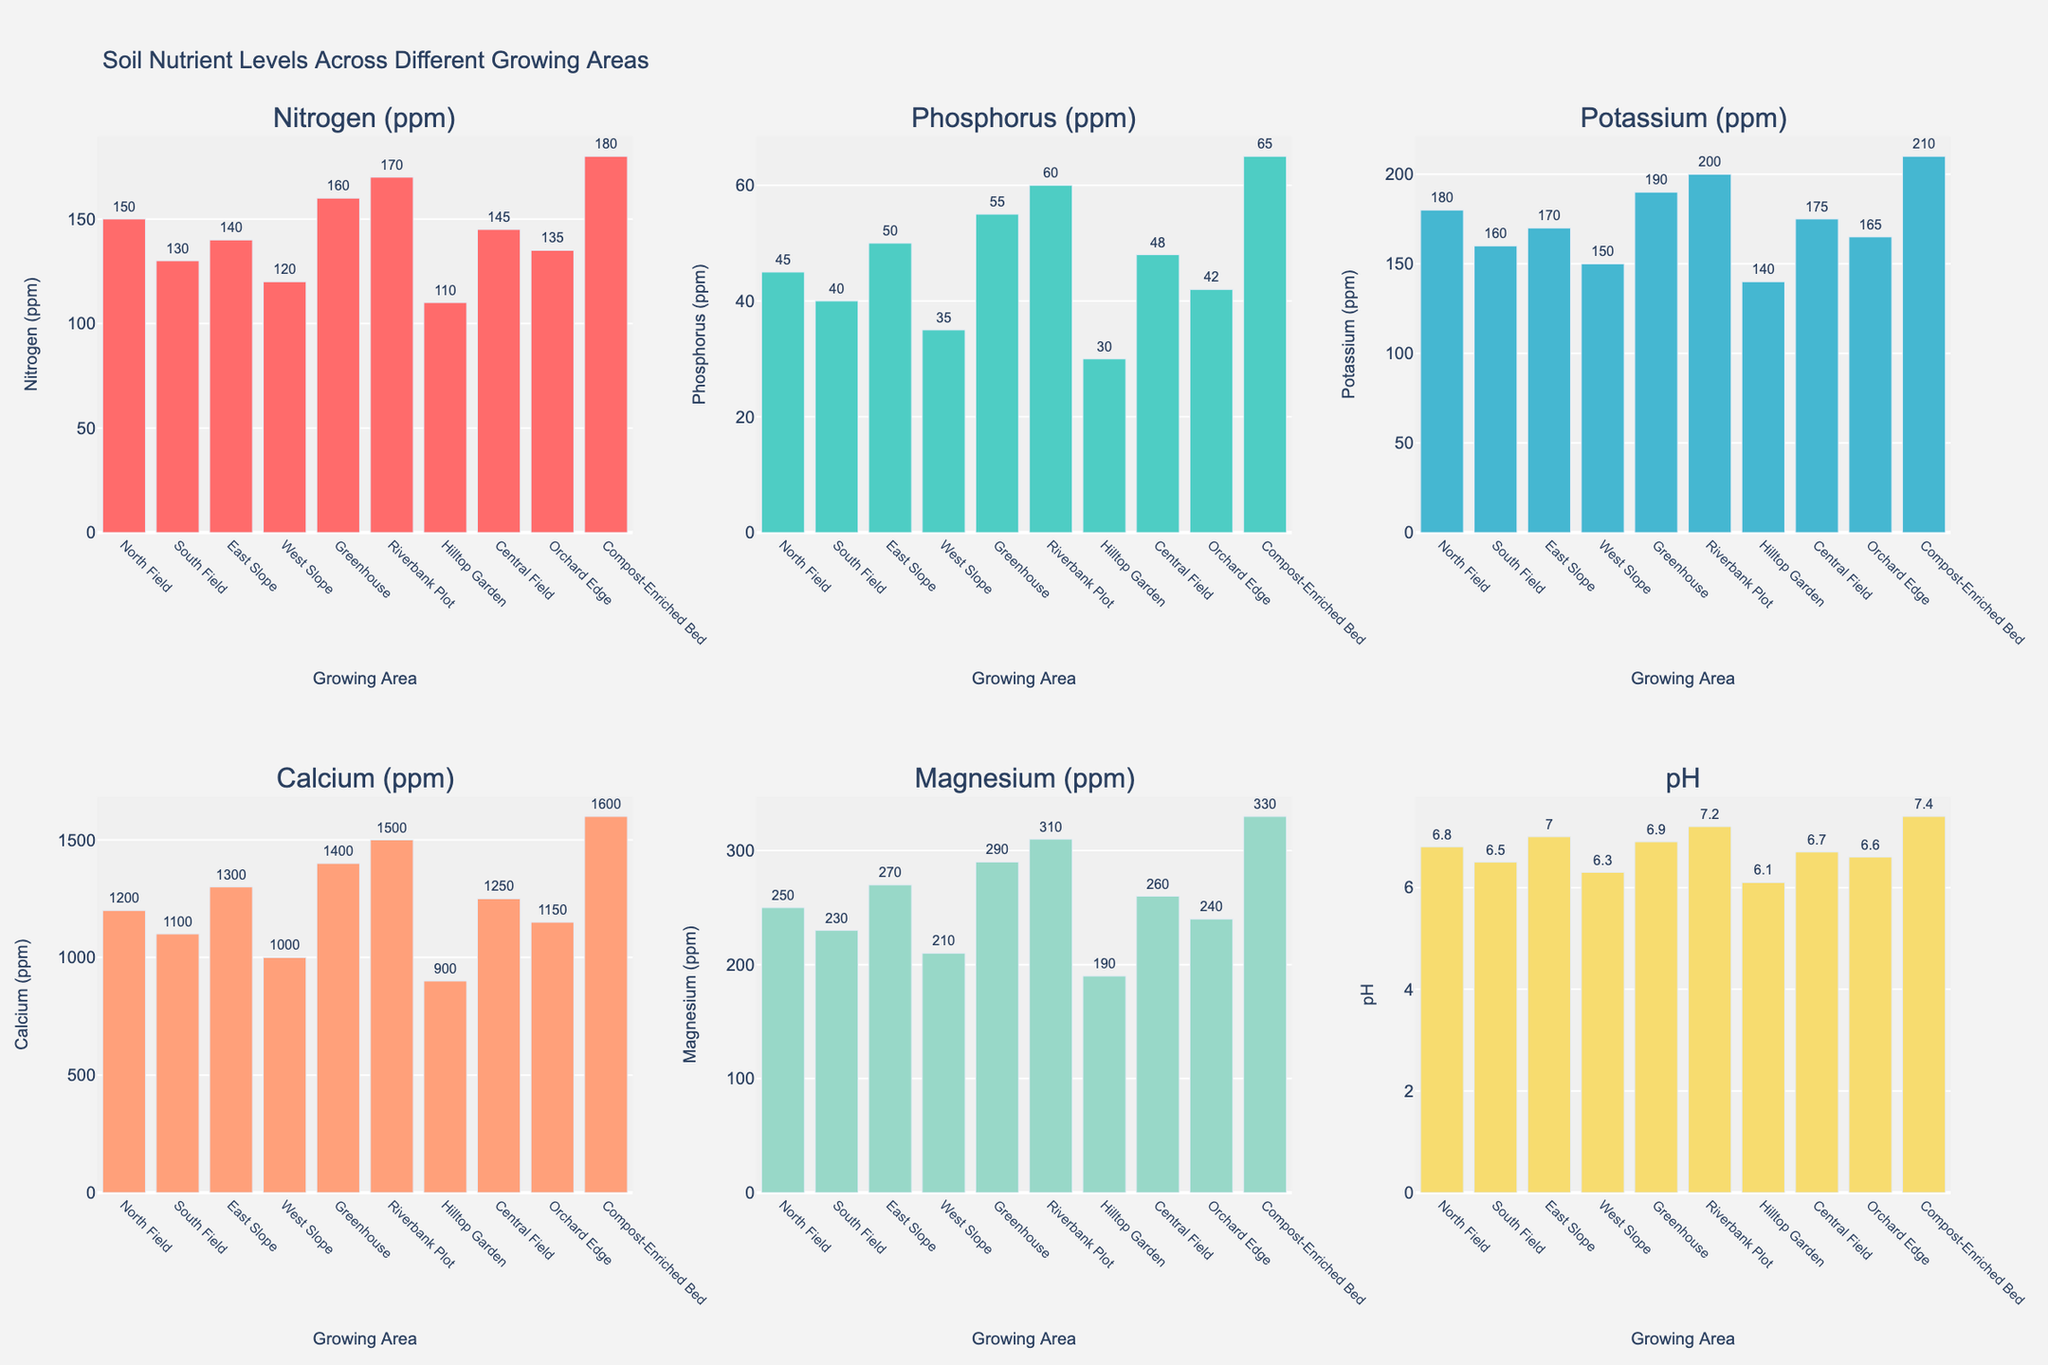Which growing area has the highest nitrogen level? Observe the bar heights in the Nitrogen (ppm) subplot. The tallest bar corresponds to Compost-Enriched Bed, which has the highest nitrogen level.
Answer: Compost-Enriched Bed Compare the phosphorus levels between the Greenhouse and the Riverbank Plot. Which one is higher? In the Phosphorus (ppm) subplot, compare the bar heights for Greenhouse and Riverbank Plot. The bar for Riverbank Plot is higher.
Answer: Riverbank Plot What is the difference in potassium levels between the Hilltop Garden and the Central Field? Look at the Potassium (ppm) subplot. The bar for Hilltop Garden is at 140 ppm and for Central Field, it is at 175 ppm. The difference is 175 - 140 = 35 ppm.
Answer: 35 ppm Which area has the lowest calcium level? Check the Calcium (ppm) subplot for the shortest bar. The shortest bar corresponds to Hilltop Garden.
Answer: Hilltop Garden Determine the average magnesium level for the North Field, South Field, and East Slope. Find the magnesium levels for North Field (250 ppm), South Field (230 ppm), and East Slope (270 ppm). Calculate the average: (250 + 230 + 270) / 3 = 750 / 3 = 250 ppm.
Answer: 250 ppm Which growing area has the highest soil pH level? Look at the soil pH subplot and find the tallest bar, which corresponds to Compost-Enriched Bed.
Answer: Compost-Enriched Bed How does the nitrogen level of the Orchard Edge compare to the South Field? In the Nitrogen (ppm) subplot, compare the bar heights of Orchard Edge (135 ppm) and South Field (130 ppm). Orchard Edge has a slightly higher nitrogen level.
Answer: Orchard Edge Which nutrient shows the greatest variance among the different growing areas? Compare the variation in bar heights across all subplots. Calcium (ppm) shows a significant range from 900 ppm to 1600 ppm, indicating the greatest variance.
Answer: Calcium (ppm) Rank the growing areas based on their potassium levels from highest to lowest. Look at the Potassium (ppm) subplot and rank the bars from tallest to shortest: Compost-Enriched Bed (210 ppm), Riverbank Plot (200 ppm), Greenhouse (190 ppm), Central Field (175 ppm), North Field (180 ppm), East Slope (170 ppm), Orchard Edge (165 ppm), South Field (160 ppm), West Slope (150 ppm), Hilltop Garden (140 ppm).
Answer: Compost-Enriched Bed, Riverbank Plot, Greenhouse, Central Field, North Field, East Slope, Orchard Edge, South Field, West Slope, Hilltop Garden Compare the calcium levels in the West Slope and Greenhouse, then compute the ratio of Greenhouse calcium to West Slope calcium. In the Calcium (ppm) subplot, the Greenhouse has 1400 ppm and the West Slope has 1000 ppm. The ratio is 1400 / 1000 = 1.4.
Answer: 1.4 